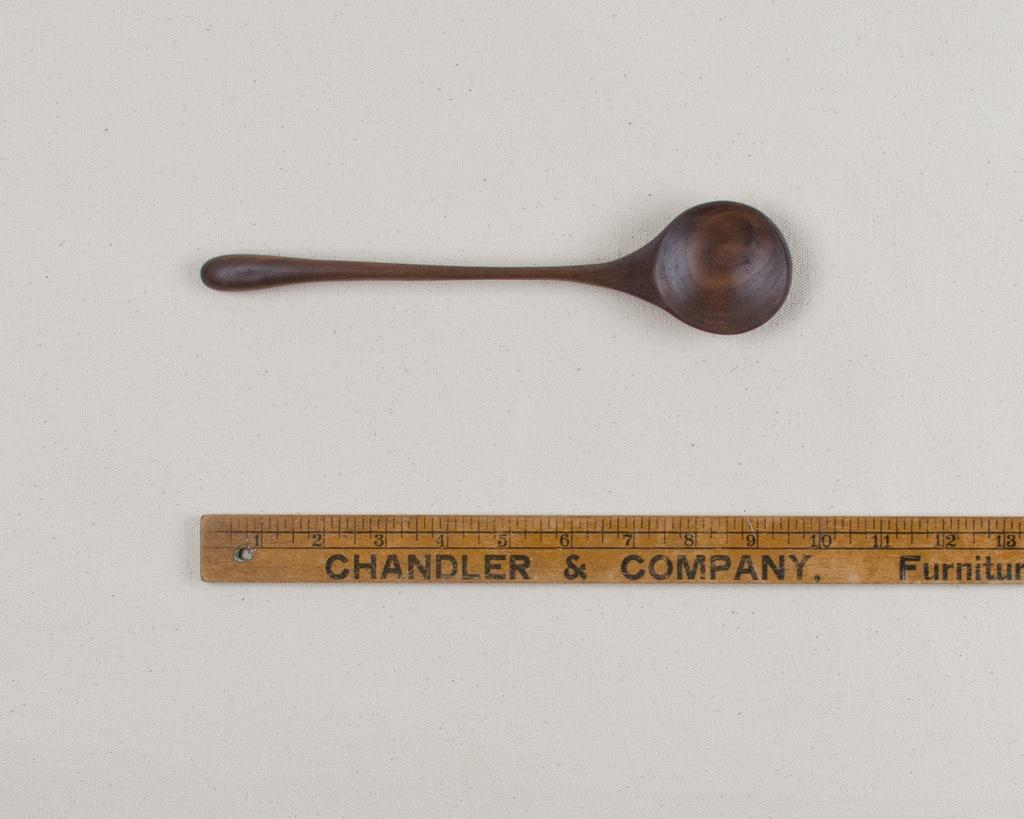<image>
Present a compact description of the photo's key features. A wooden spoon lays above a ruler by Chandler & Company. 